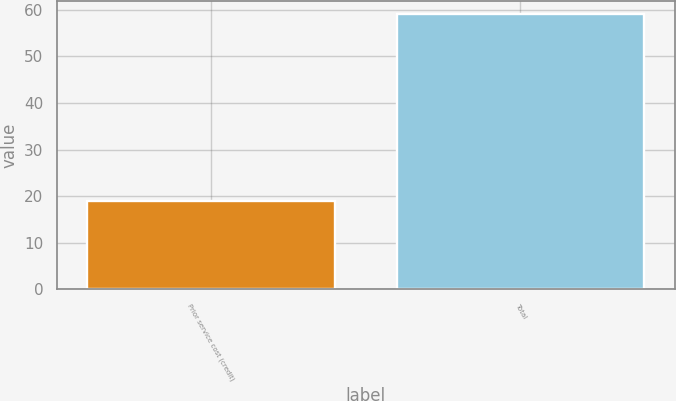Convert chart. <chart><loc_0><loc_0><loc_500><loc_500><bar_chart><fcel>Prior service cost (credit)<fcel>Total<nl><fcel>19<fcel>59<nl></chart> 